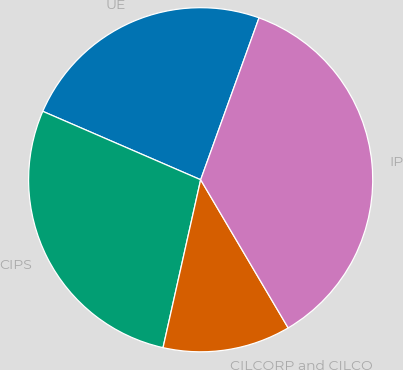<chart> <loc_0><loc_0><loc_500><loc_500><pie_chart><fcel>UE<fcel>CIPS<fcel>CILCORP and CILCO<fcel>IP<nl><fcel>24.0%<fcel>28.0%<fcel>12.0%<fcel>36.0%<nl></chart> 